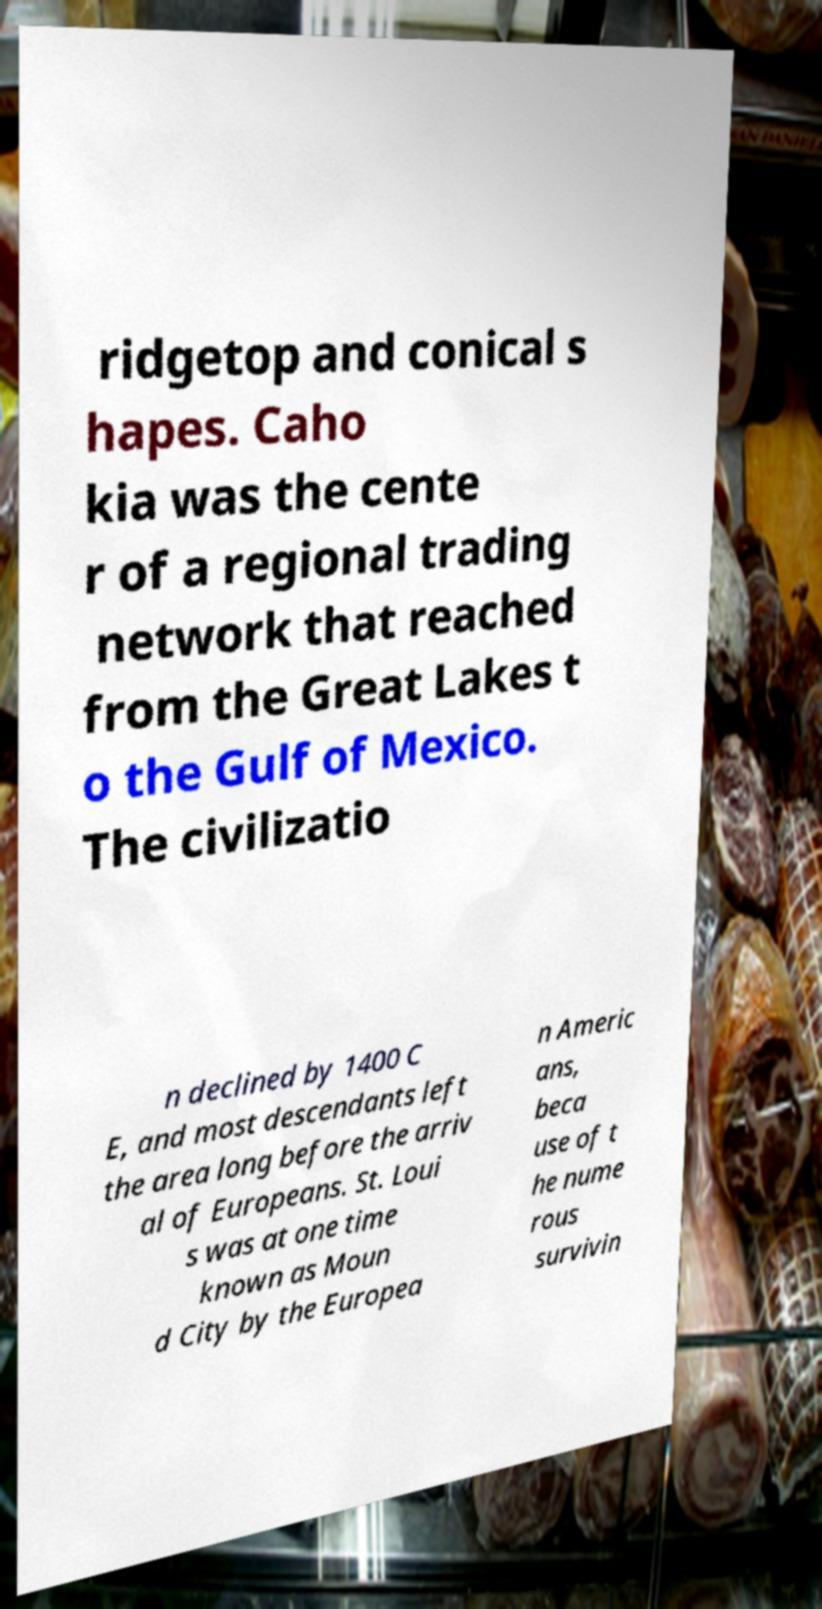Please identify and transcribe the text found in this image. ridgetop and conical s hapes. Caho kia was the cente r of a regional trading network that reached from the Great Lakes t o the Gulf of Mexico. The civilizatio n declined by 1400 C E, and most descendants left the area long before the arriv al of Europeans. St. Loui s was at one time known as Moun d City by the Europea n Americ ans, beca use of t he nume rous survivin 